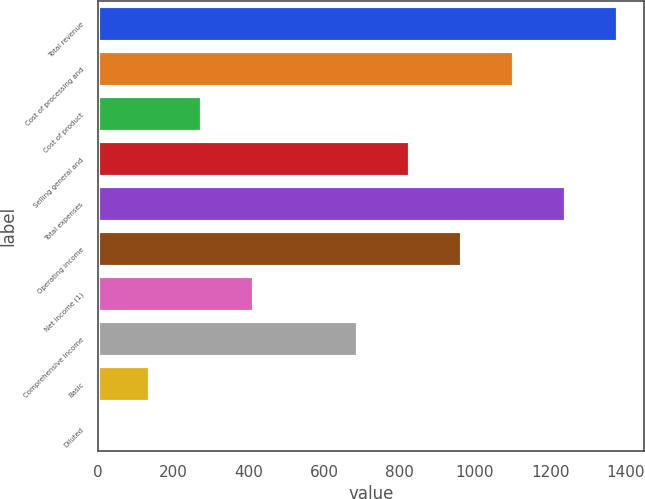Convert chart. <chart><loc_0><loc_0><loc_500><loc_500><bar_chart><fcel>Total revenue<fcel>Cost of processing and<fcel>Cost of product<fcel>Selling general and<fcel>Total expenses<fcel>Operating income<fcel>Net income (1)<fcel>Comprehensive income<fcel>Basic<fcel>Diluted<nl><fcel>1380<fcel>1104.16<fcel>276.76<fcel>828.36<fcel>1242.06<fcel>966.26<fcel>414.66<fcel>690.46<fcel>138.86<fcel>0.96<nl></chart> 